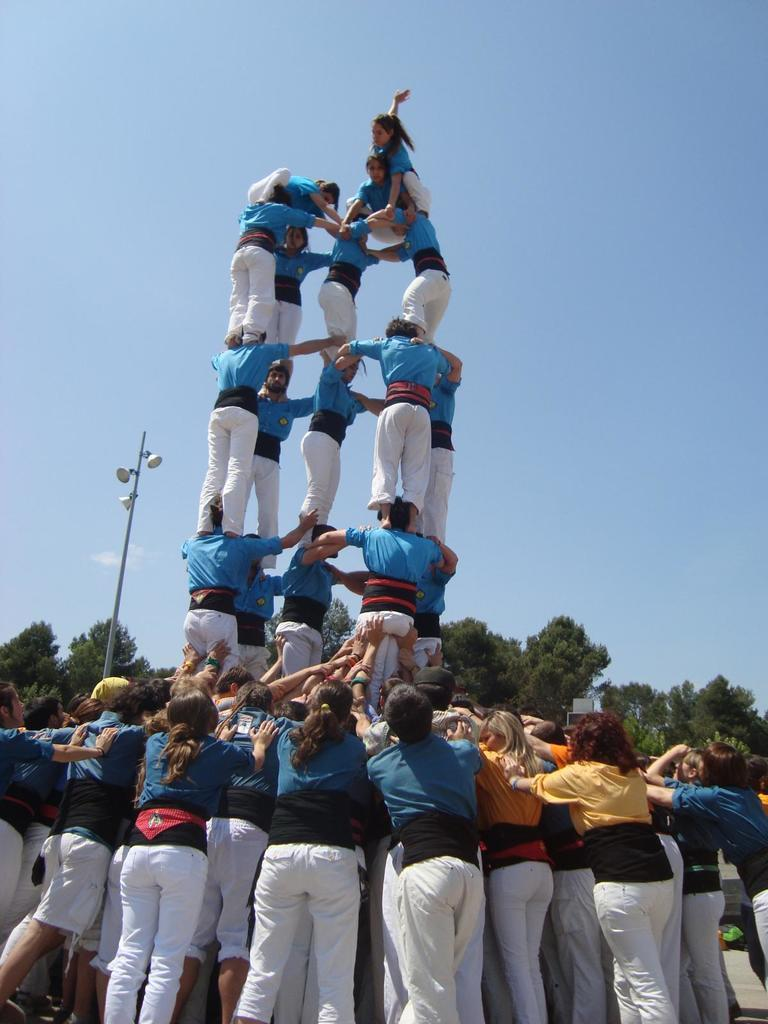How are the people arranged in the image? The people are standing in a pyramid formation in the image. What can be seen in the background of the image? There are trees in the background of the image. What is on the left side of the image? There is a street light on the left side of the image. What is visible above the people and trees in the image? The sky is visible above the people and trees in the image. What type of yoke is being used by the people in the image? There is no yoke present in the image; the people are standing in a pyramid formation without any yokes. What time of day is it in the image, considering the afternoon? The time of day cannot be determined from the image alone, as there is no indication of the time or the presence of the afternoon. 